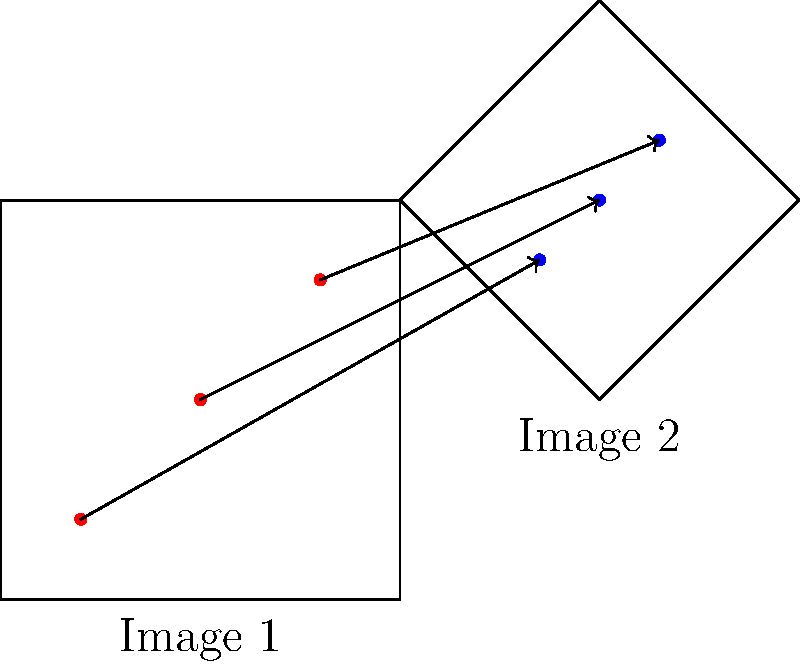Consider two images of the same object taken from different viewing angles, as shown in the diagram. Image 2 is a rotated and scaled version of Image 1. If we apply the Scale-Invariant Feature Transform (SIFT) to both images, which of the following statements is true about the SIFT keypoints and descriptors?

A) The number of keypoints will be identical in both images.
B) The descriptors for corresponding keypoints will be exactly the same.
C) The relative positions of keypoints within each image will be preserved.
D) The number of keypoints and their descriptors will be completely different. Let's analyze this step-by-step:

1. SIFT Keypoint Detection:
   - SIFT detects keypoints at different scales and locations in the image.
   - The number of keypoints may vary between the two images due to differences in viewing angle and scale.

2. SIFT Descriptor Computation:
   - For each keypoint, SIFT computes a descriptor based on local gradient information.
   - The descriptor is designed to be invariant to rotation and scale changes.

3. Keypoint Correspondence:
   - Despite changes in scale and rotation, SIFT aims to find corresponding keypoints between the two images.
   - The relative positions of keypoints within each image should be maintained, even if the absolute positions change.

4. Descriptor Similarity:
   - While not exactly the same due to noise and viewing angle changes, descriptors for corresponding keypoints should be similar enough to allow matching.

5. Scale and Rotation Invariance:
   - SIFT is designed to be invariant to scale changes and rotation, which is crucial for this scenario.

Given these considerations:
- A is incorrect because the number of keypoints may differ due to viewing angle changes.
- B is incorrect because descriptors won't be exactly the same due to viewing angle differences and image noise.
- D is incorrect because while there may be some differences, SIFT is designed to find correspondences between the images.
- C is correct because SIFT preserves the relative positions of keypoints within each image, allowing for successful matching despite scale and rotation changes.
Answer: C 